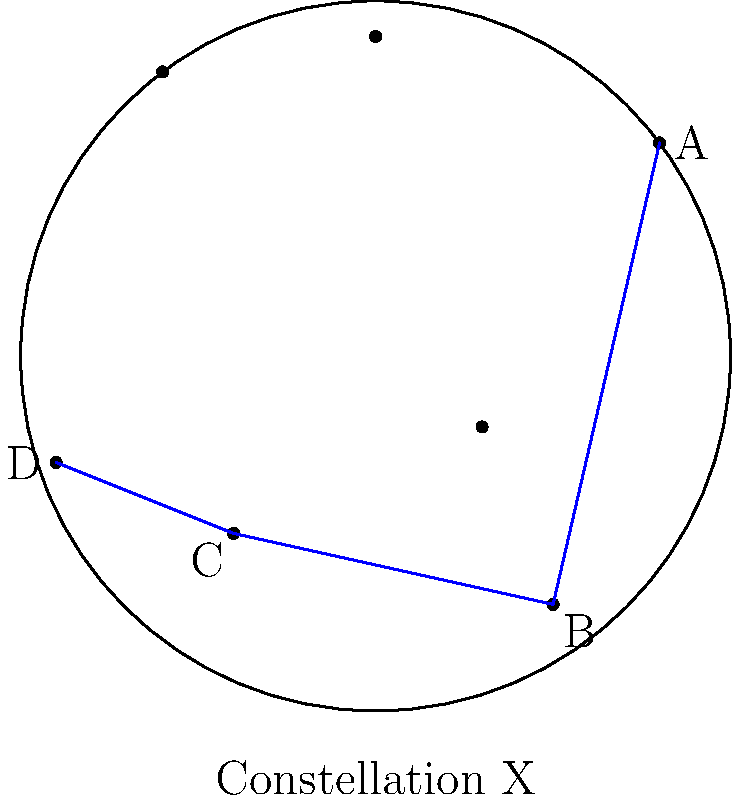Using the star chart provided, which stars form the constellation labeled "Constellation X"? To identify the stars that form "Constellation X" in the given star chart, follow these steps:

1. Observe the star chart carefully. You'll see several dots representing stars and some lines connecting them.

2. Notice that there are blue lines connecting some of the stars. These lines represent the shape of a constellation.

3. The blue lines form a distinct pattern, connecting four stars in the chart.

4. Identify the labeled stars that are connected by the blue lines:
   - Star A (top right)
   - Star B (bottom right)
   - Star C (bottom left)
   - Star D (left)

5. The constellation is formed by connecting these stars in the order: A to B to C to D.

6. At the bottom of the chart, you can see the label "Constellation X," confirming that this is the constellation we're looking for.

Therefore, the stars that form "Constellation X" are the ones labeled A, B, C, and D, connected in that order.
Answer: Stars A, B, C, and D 